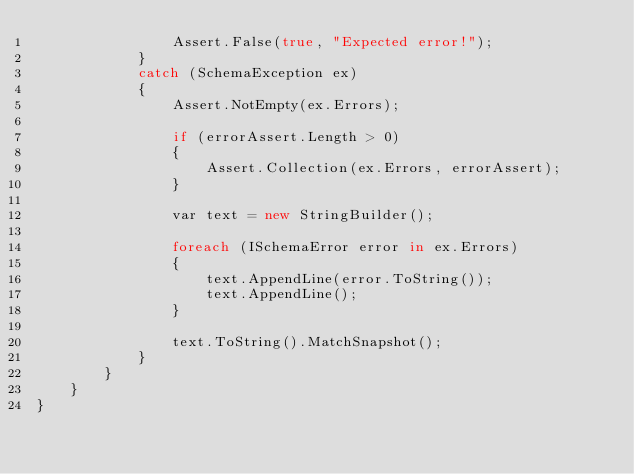<code> <loc_0><loc_0><loc_500><loc_500><_C#_>                Assert.False(true, "Expected error!");
            }
            catch (SchemaException ex)
            {
                Assert.NotEmpty(ex.Errors);

                if (errorAssert.Length > 0)
                {
                    Assert.Collection(ex.Errors, errorAssert);
                }

                var text = new StringBuilder();

                foreach (ISchemaError error in ex.Errors)
                {
                    text.AppendLine(error.ToString());
                    text.AppendLine();
                }

                text.ToString().MatchSnapshot();
            }
        }
    }
}
</code> 